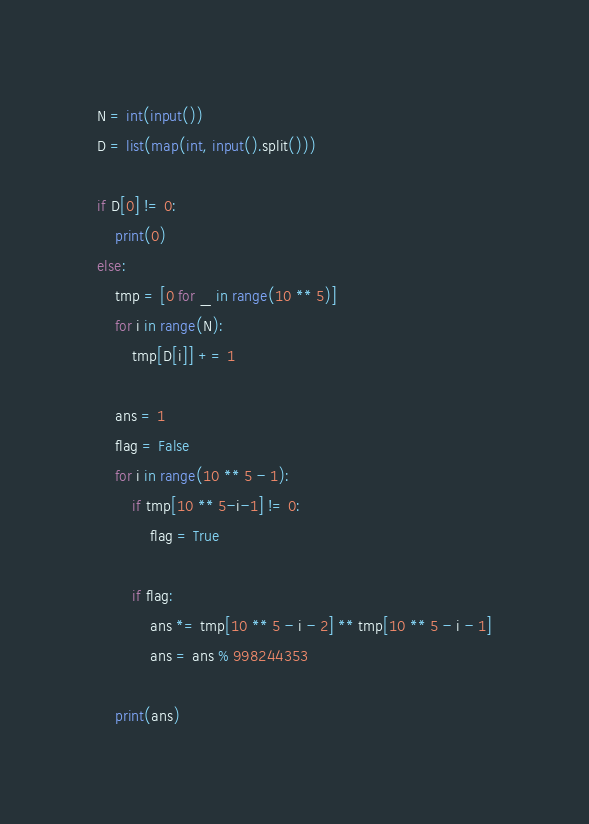Convert code to text. <code><loc_0><loc_0><loc_500><loc_500><_Python_>N = int(input())
D = list(map(int, input().split()))

if D[0] != 0:
    print(0)
else:
    tmp = [0 for _ in range(10 ** 5)]
    for i in range(N):
        tmp[D[i]] += 1

    ans = 1
    flag = False
    for i in range(10 ** 5 - 1):
        if tmp[10 ** 5-i-1] != 0:
            flag = True

        if flag:
            ans *= tmp[10 ** 5 - i - 2] ** tmp[10 ** 5 - i - 1]
            ans = ans % 998244353

    print(ans) 
</code> 